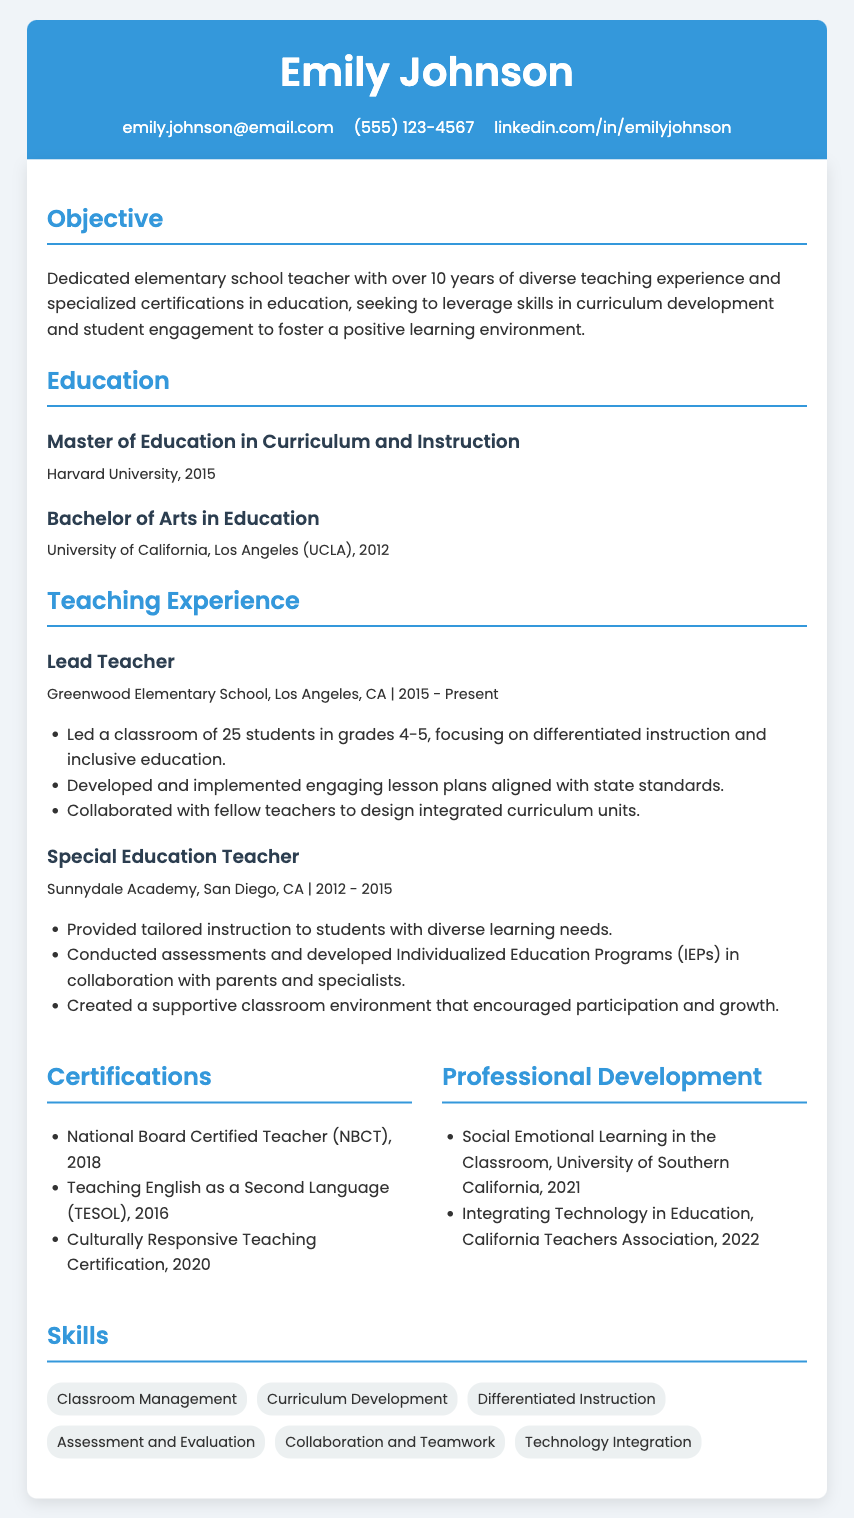What is Emily Johnson's email address? The email address is provided in the contact information section of the resume.
Answer: emily.johnson@email.com Where did Emily obtain her Master of Education? The document lists the education background, showing where degrees were earned.
Answer: Harvard University What teaching role did Emily hold at Greenwood Elementary School? The document specifies her position at Greenwood Elementary School under the teaching experience section.
Answer: Lead Teacher In which year did Emily receive her National Board Certification? The certification information includes specific years when each was obtained.
Answer: 2018 What certification is related to teaching English? The certifications include specialized areas of training relevant to teaching methods.
Answer: Teaching English as a Second Language (TESOL) How many years of teaching experience does Emily have? The objective section mentions her overall experience in teaching.
Answer: over 10 years Which specialized certification did Emily earn in 2020? The certifications indicate the year each was obtained along with their focus areas.
Answer: Culturally Responsive Teaching Certification What is one of the skills listed in Emily's resume? The skills section outlines various competencies relevant to teaching.
Answer: Classroom Management What university did Emily attend for her Bachelor's degree? The education section provides details of the institutions where she studied.
Answer: University of California, Los Angeles (UCLA) 